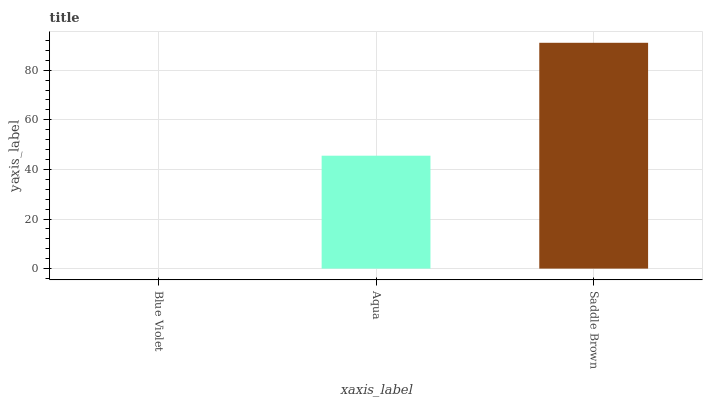Is Blue Violet the minimum?
Answer yes or no. Yes. Is Saddle Brown the maximum?
Answer yes or no. Yes. Is Aqua the minimum?
Answer yes or no. No. Is Aqua the maximum?
Answer yes or no. No. Is Aqua greater than Blue Violet?
Answer yes or no. Yes. Is Blue Violet less than Aqua?
Answer yes or no. Yes. Is Blue Violet greater than Aqua?
Answer yes or no. No. Is Aqua less than Blue Violet?
Answer yes or no. No. Is Aqua the high median?
Answer yes or no. Yes. Is Aqua the low median?
Answer yes or no. Yes. Is Blue Violet the high median?
Answer yes or no. No. Is Saddle Brown the low median?
Answer yes or no. No. 